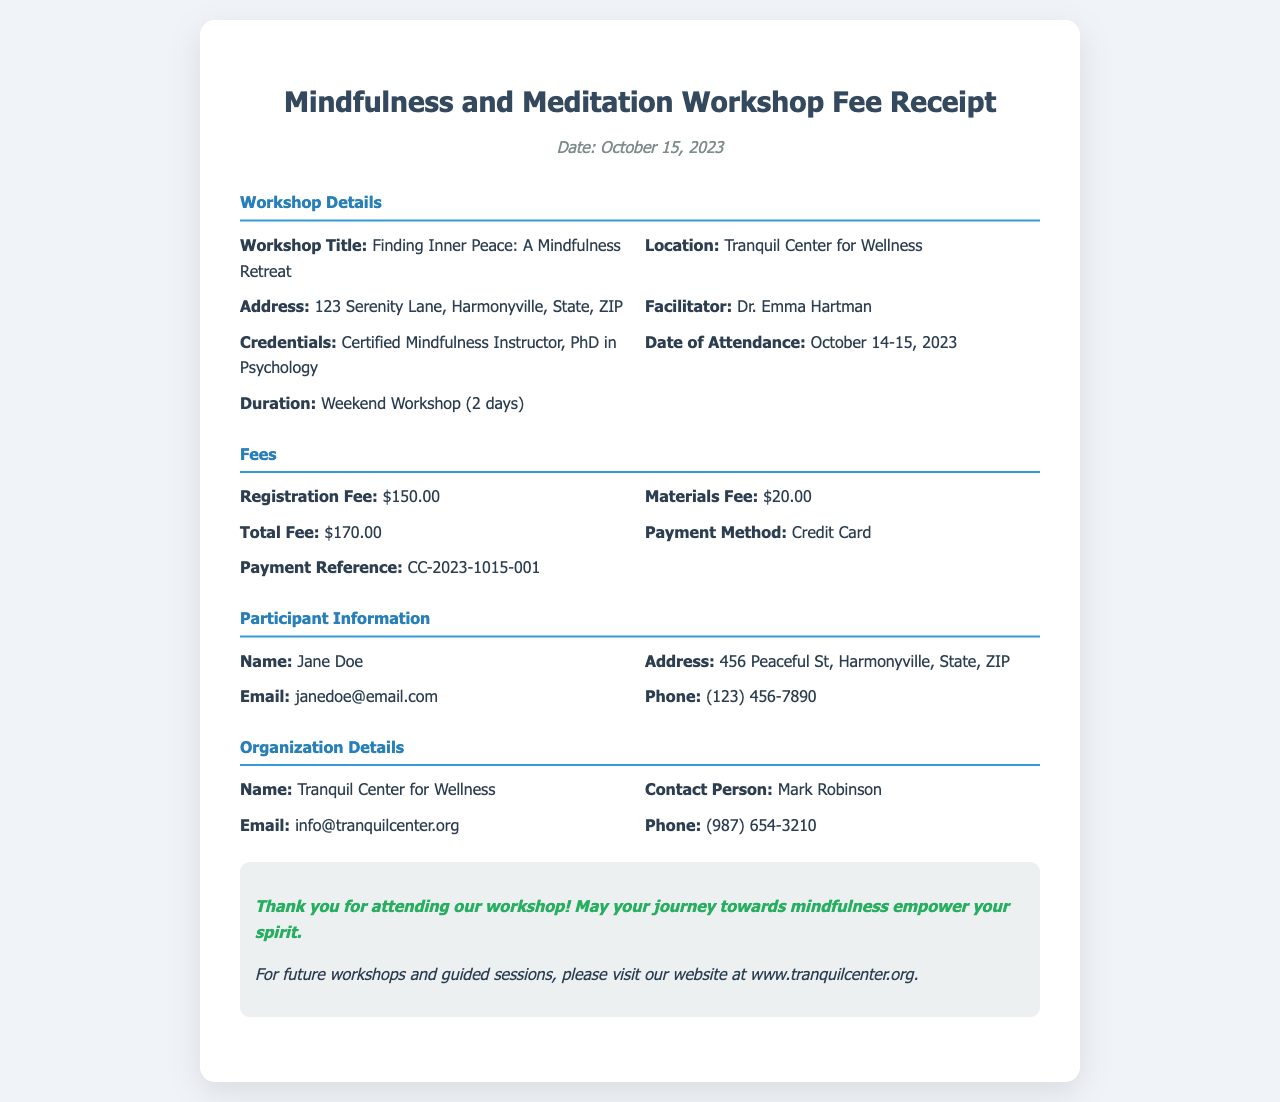What is the workshop title? The workshop title is explicitly stated in the document as "Finding Inner Peace: A Mindfulness Retreat."
Answer: Finding Inner Peace: A Mindfulness Retreat Who is the facilitator of the workshop? The facilitator's name is provided in the workshop details section.
Answer: Dr. Emma Hartman What is the total fee for the workshop? The total fee is listed in the fees section as the sum of the registration and materials fee.
Answer: $170.00 When did the workshop take place? The dates for the workshop are noted in the document as October 14-15, 2023.
Answer: October 14-15, 2023 What payment method was used? The payment method used for the workshop is explicitly mentioned in the fees section.
Answer: Credit Card How much was the registration fee? The registration fee is mentioned in the fees section.
Answer: $150.00 What is the address of the workshop location? The address is detailed under the workshop details section.
Answer: 123 Serenity Lane, Harmonyville, State, ZIP What is the contact email for the Tranquil Center for Wellness? The contact email is provided in the organization details section of the document.
Answer: info@tranquilcenter.org Who attended the workshop? The participant's information is given, including the name, which identifies the attendee.
Answer: Jane Doe 